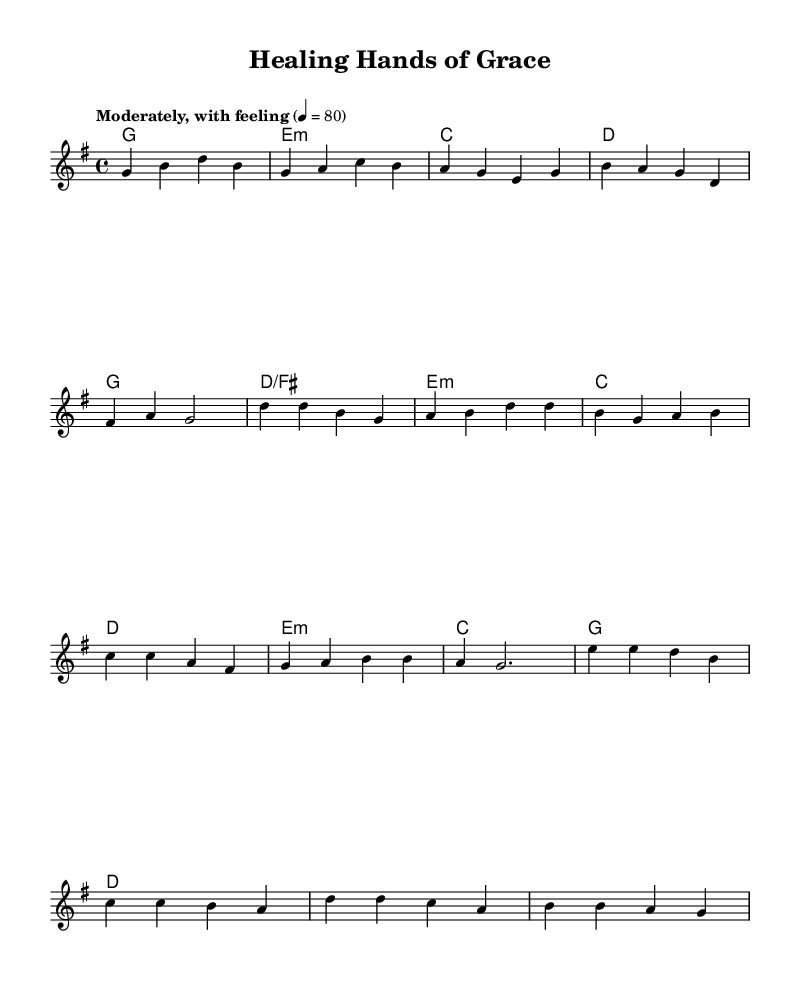What is the key signature of this music? The key signature is G major, identified by one sharp (F#) on the staff.
Answer: G major What is the time signature of this piece? The time signature is 4/4, which means there are four beats in a measure and a quarter note receives one beat.
Answer: 4/4 What is the tempo marking for the song? The tempo is marked as "Moderately, with feeling," indicating a moderate pace.
Answer: Moderately, with feeling How many measures are in the verse section? The verse section contains four measures that are identifiable by the lyrics written underneath the notes.
Answer: Four measures What is the last line of the lyrics in the bridge? The last line of the lyrics in the bridge is "As we lean on You," which is clearly indicated in the lyrics.
Answer: As we lean on You Which lyrical section has the line "Restore us, make us whole"? This line is in the chorus, which follows the verse section and is indicated by the lyrics.
Answer: Chorus What is the main theme of this song based on the lyrics provided? The main theme centers around healing and restoration, evident from repeated references to healing hands and trust in divine power.
Answer: Healing and restoration 